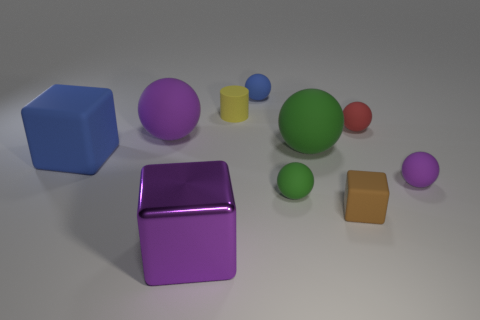Subtract all blue spheres. How many spheres are left? 5 Subtract all big purple rubber spheres. How many spheres are left? 5 Subtract all red spheres. Subtract all red cylinders. How many spheres are left? 5 Subtract all blocks. How many objects are left? 7 Add 7 red matte balls. How many red matte balls are left? 8 Add 10 large blue metal blocks. How many large blue metal blocks exist? 10 Subtract 0 brown balls. How many objects are left? 10 Subtract all big green rubber balls. Subtract all large cyan rubber objects. How many objects are left? 9 